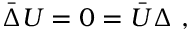<formula> <loc_0><loc_0><loc_500><loc_500>\bar { \Delta } U = 0 = \bar { U } \Delta \ ,</formula> 